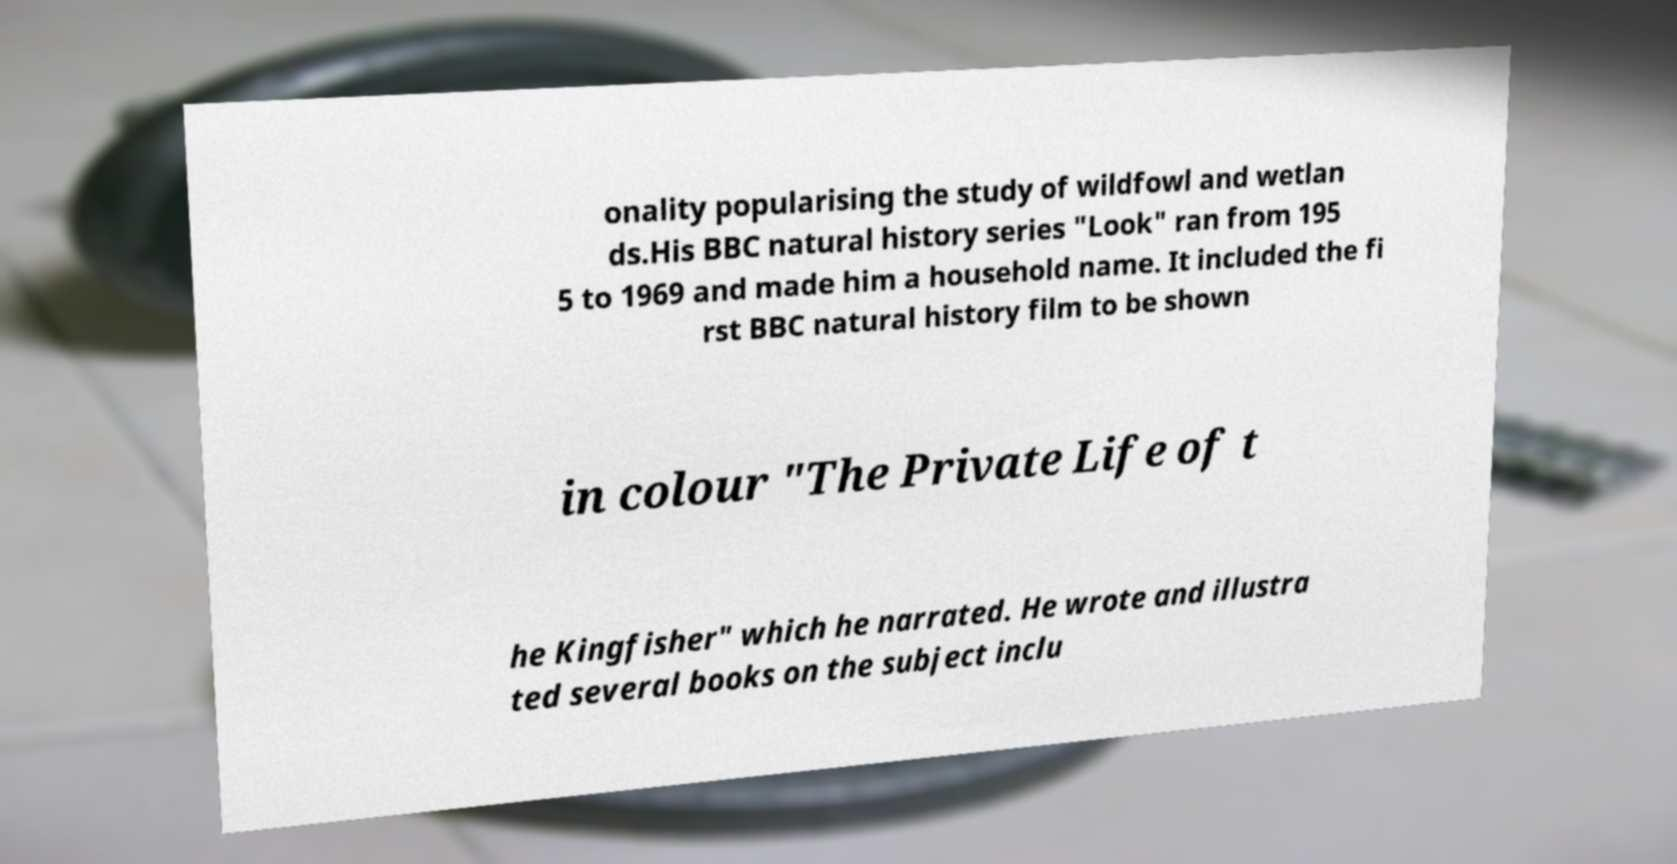For documentation purposes, I need the text within this image transcribed. Could you provide that? onality popularising the study of wildfowl and wetlan ds.His BBC natural history series "Look" ran from 195 5 to 1969 and made him a household name. It included the fi rst BBC natural history film to be shown in colour "The Private Life of t he Kingfisher" which he narrated. He wrote and illustra ted several books on the subject inclu 